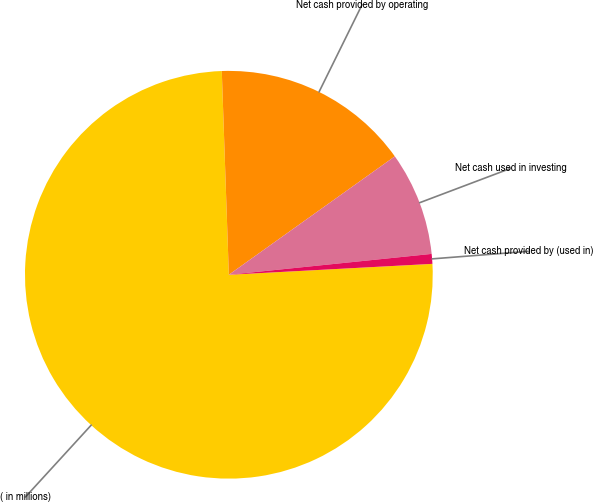Convert chart to OTSL. <chart><loc_0><loc_0><loc_500><loc_500><pie_chart><fcel>( in millions)<fcel>Net cash provided by operating<fcel>Net cash used in investing<fcel>Net cash provided by (used in)<nl><fcel>75.3%<fcel>15.69%<fcel>8.23%<fcel>0.78%<nl></chart> 